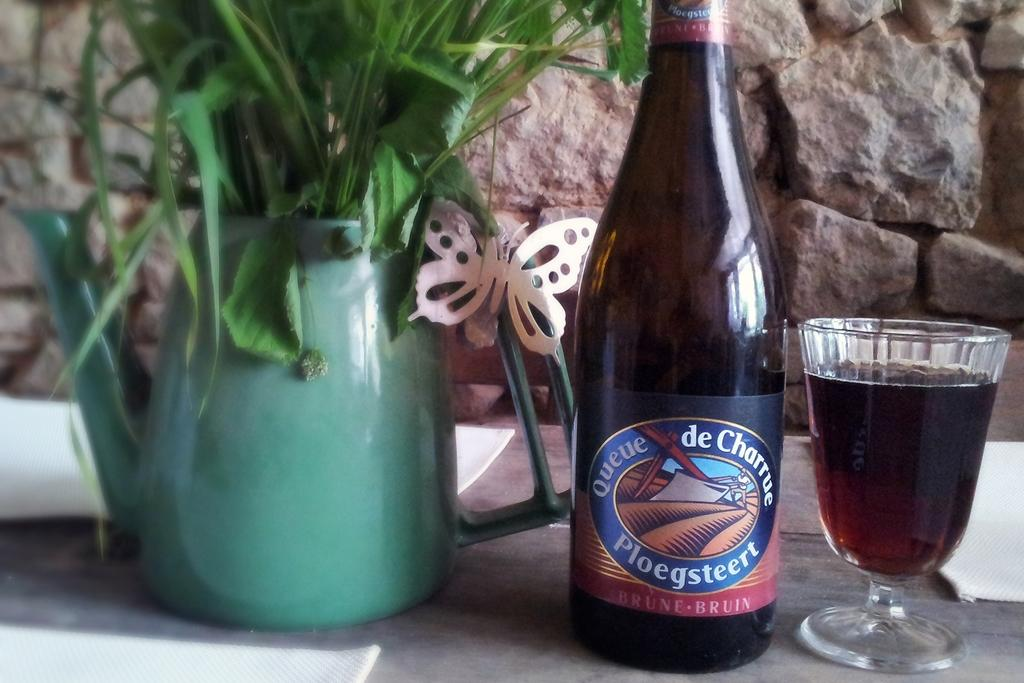<image>
Give a short and clear explanation of the subsequent image. Ploegsteert beer bottle in between a plant and a cup of beer. 